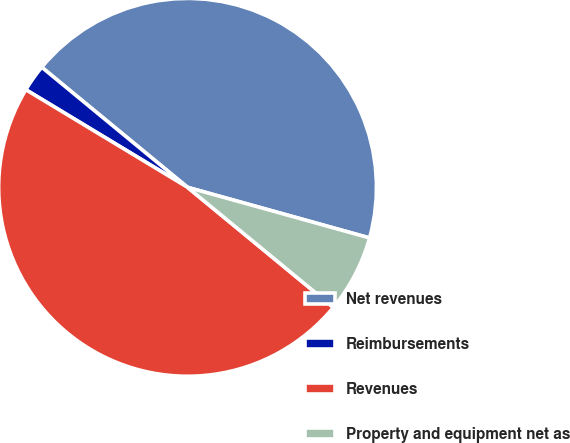Convert chart. <chart><loc_0><loc_0><loc_500><loc_500><pie_chart><fcel>Net revenues<fcel>Reimbursements<fcel>Revenues<fcel>Property and equipment net as<nl><fcel>43.35%<fcel>2.32%<fcel>47.68%<fcel>6.65%<nl></chart> 